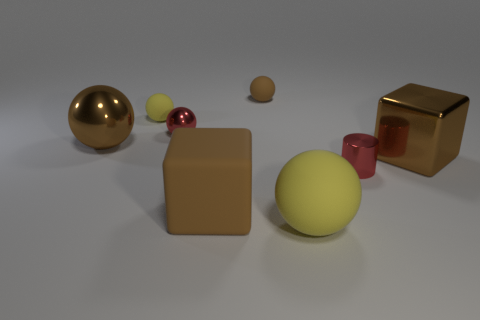Subtract all purple cubes. How many yellow spheres are left? 2 Subtract all big brown spheres. How many spheres are left? 4 Add 2 large cyan things. How many objects exist? 10 Subtract all brown spheres. How many spheres are left? 3 Subtract all balls. How many objects are left? 3 Subtract 1 cylinders. How many cylinders are left? 0 Add 3 large brown shiny objects. How many large brown shiny objects are left? 5 Add 8 big purple shiny spheres. How many big purple shiny spheres exist? 8 Subtract 0 green cylinders. How many objects are left? 8 Subtract all brown cylinders. Subtract all blue blocks. How many cylinders are left? 1 